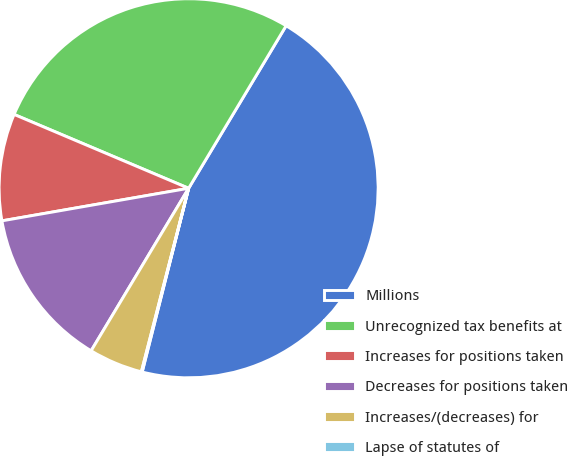<chart> <loc_0><loc_0><loc_500><loc_500><pie_chart><fcel>Millions<fcel>Unrecognized tax benefits at<fcel>Increases for positions taken<fcel>Decreases for positions taken<fcel>Increases/(decreases) for<fcel>Lapse of statutes of<nl><fcel>45.34%<fcel>27.23%<fcel>9.12%<fcel>13.65%<fcel>4.59%<fcel>0.07%<nl></chart> 